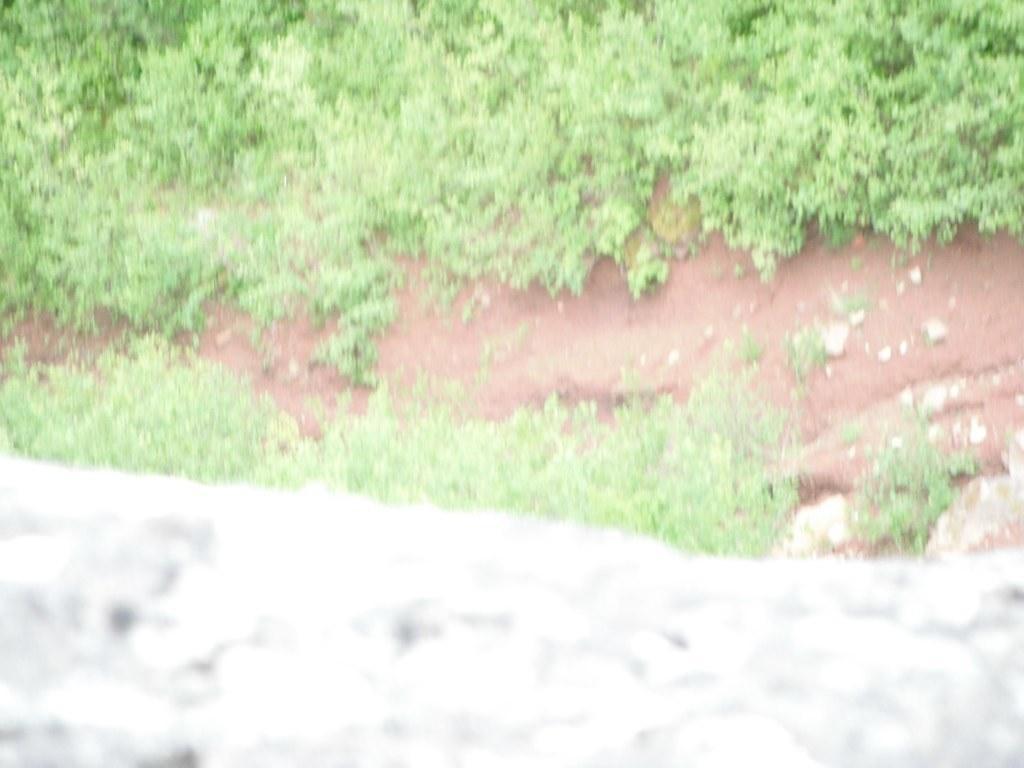Describe this image in one or two sentences. In the image there is a grass and there is a cement wall in front of the grass. 